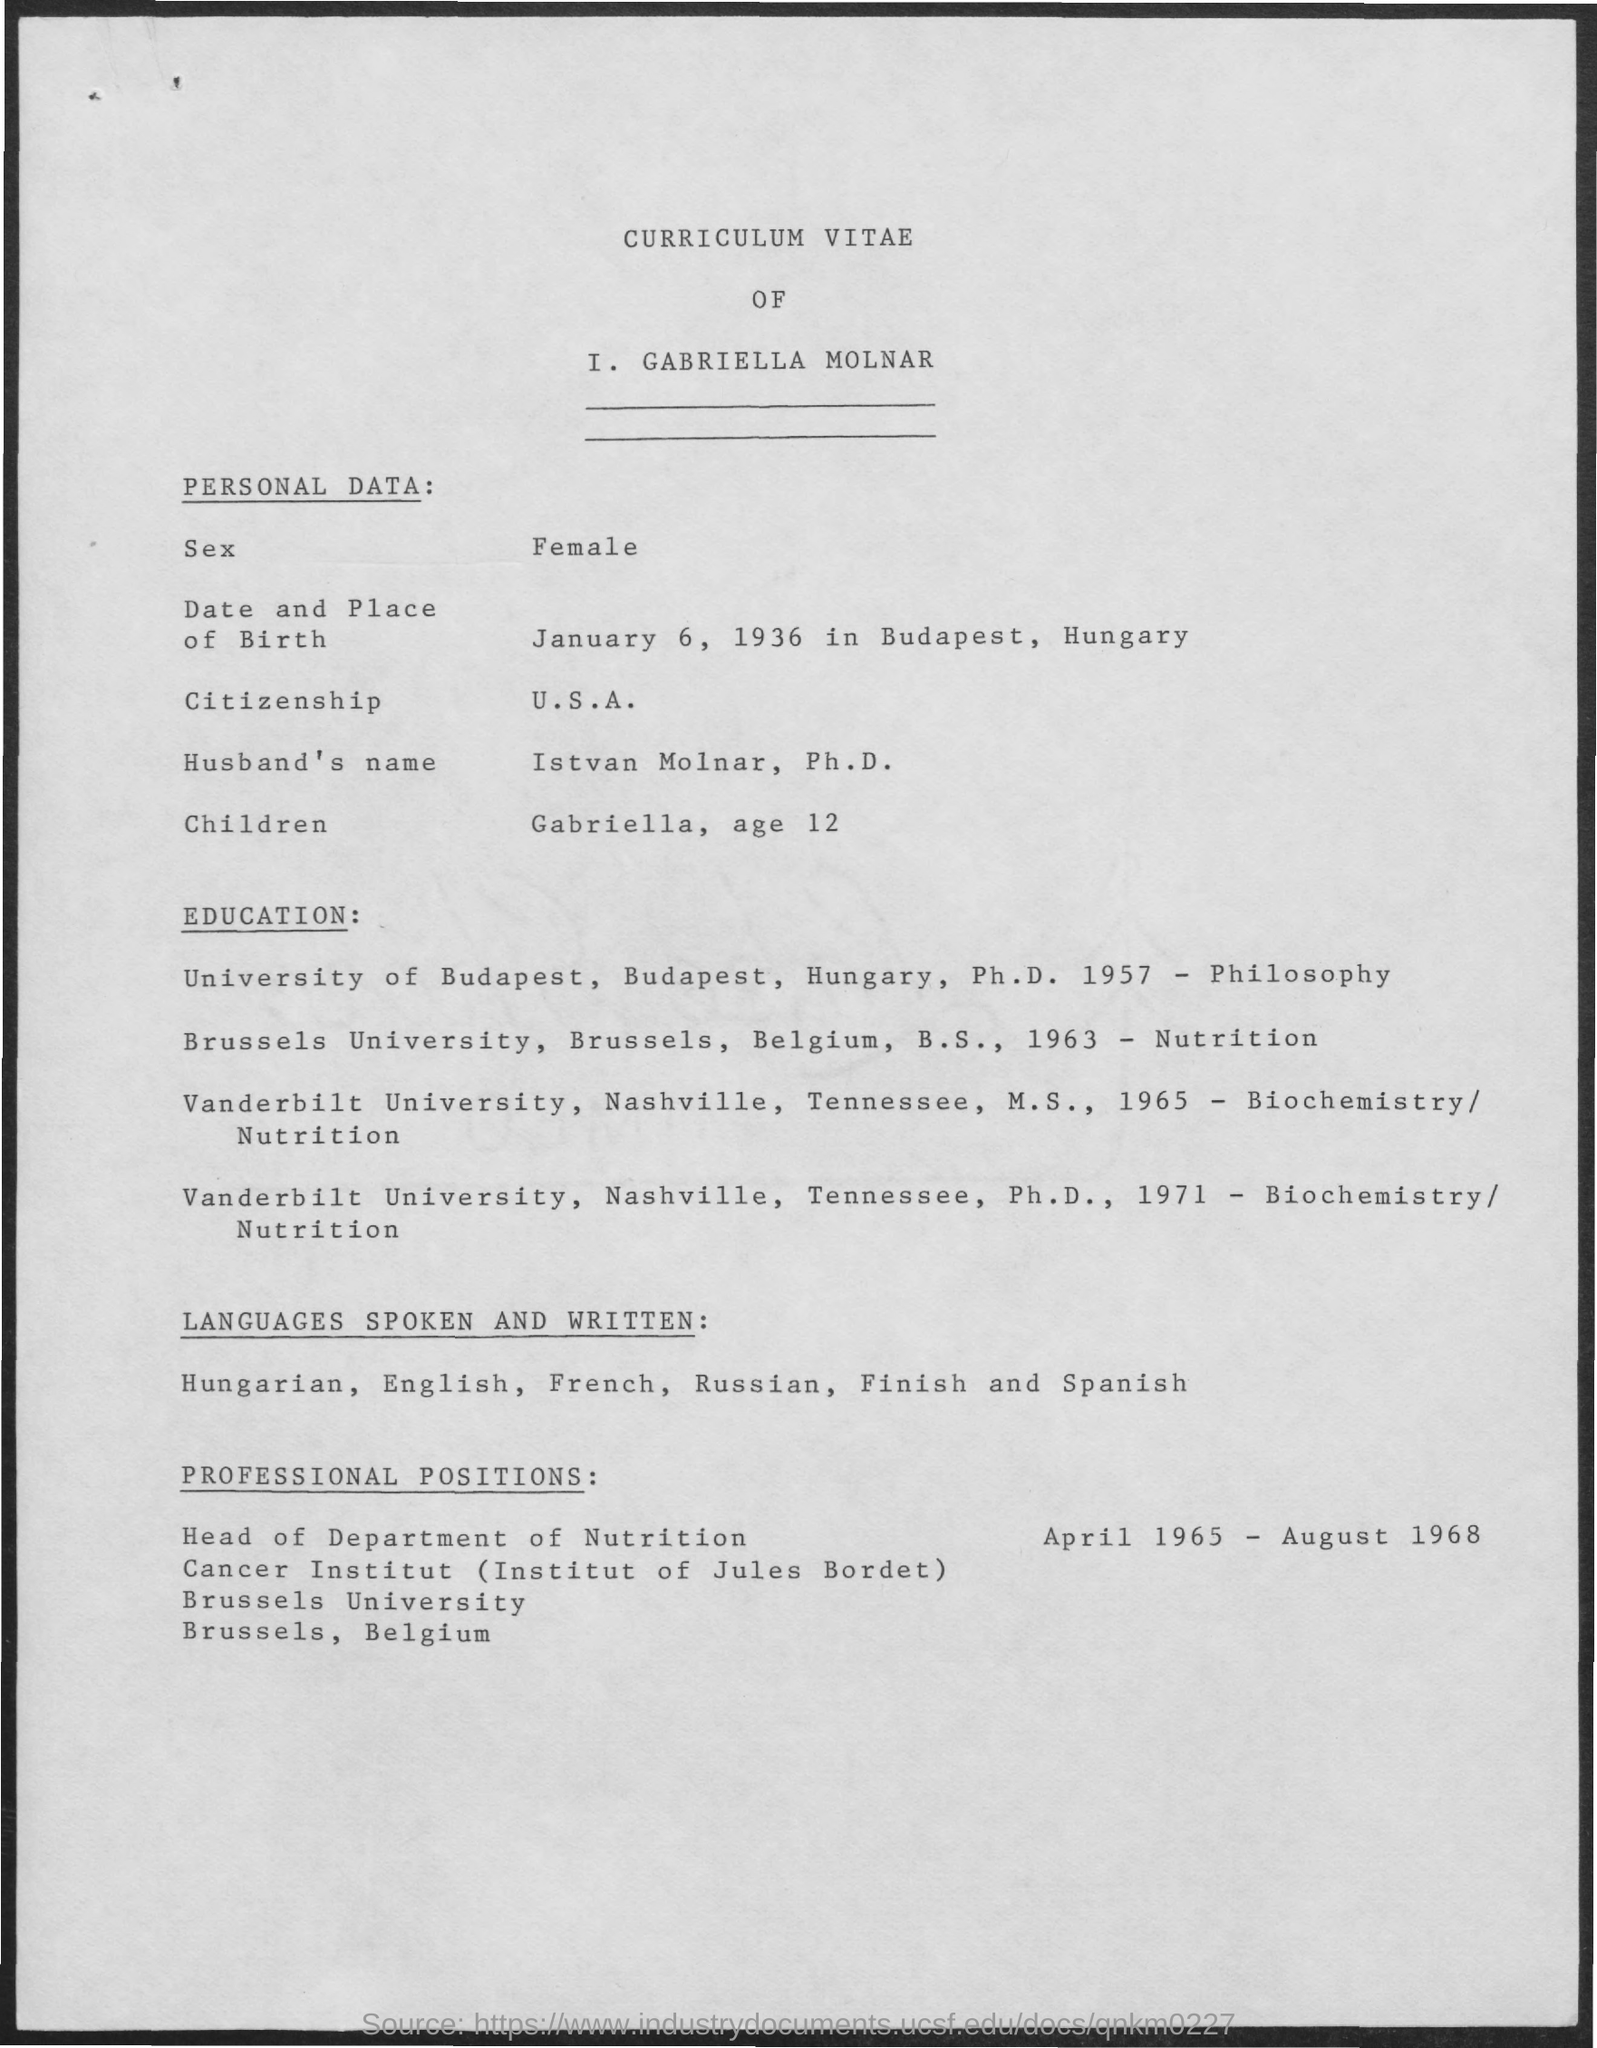Outline some significant characteristics in this image. I, I. GABRIELLA MOLNAR, am a citizen of the United States of America, The date and place of birth of I. Gabriella Molnár are January 6, 1936 in Budapest, Hungary. 